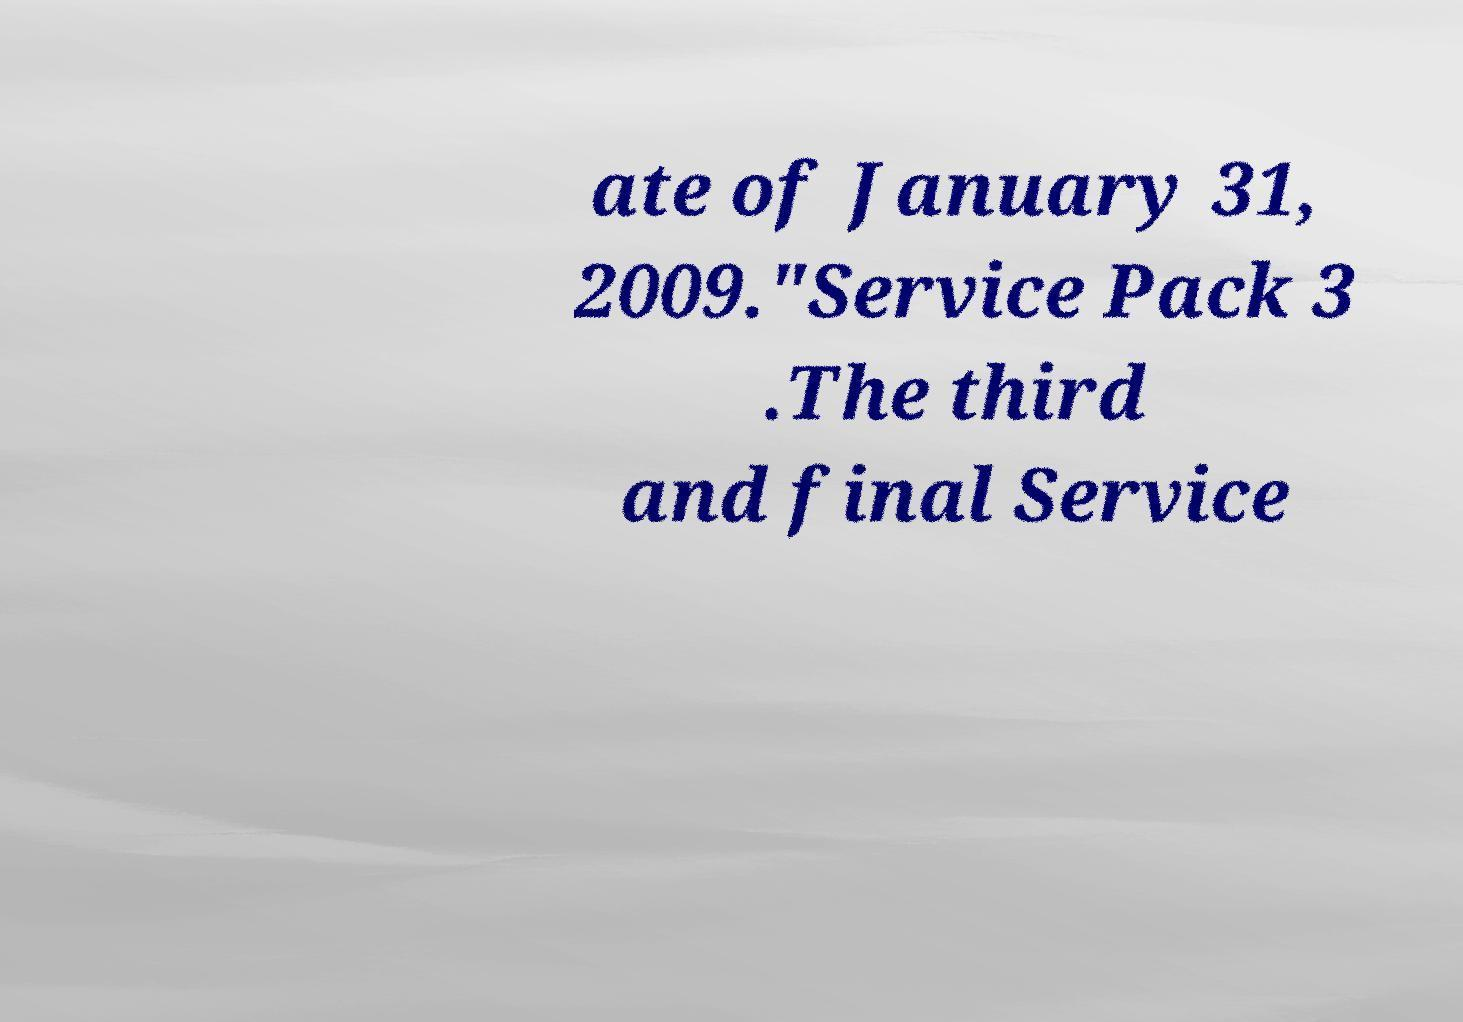Can you accurately transcribe the text from the provided image for me? ate of January 31, 2009."Service Pack 3 .The third and final Service 